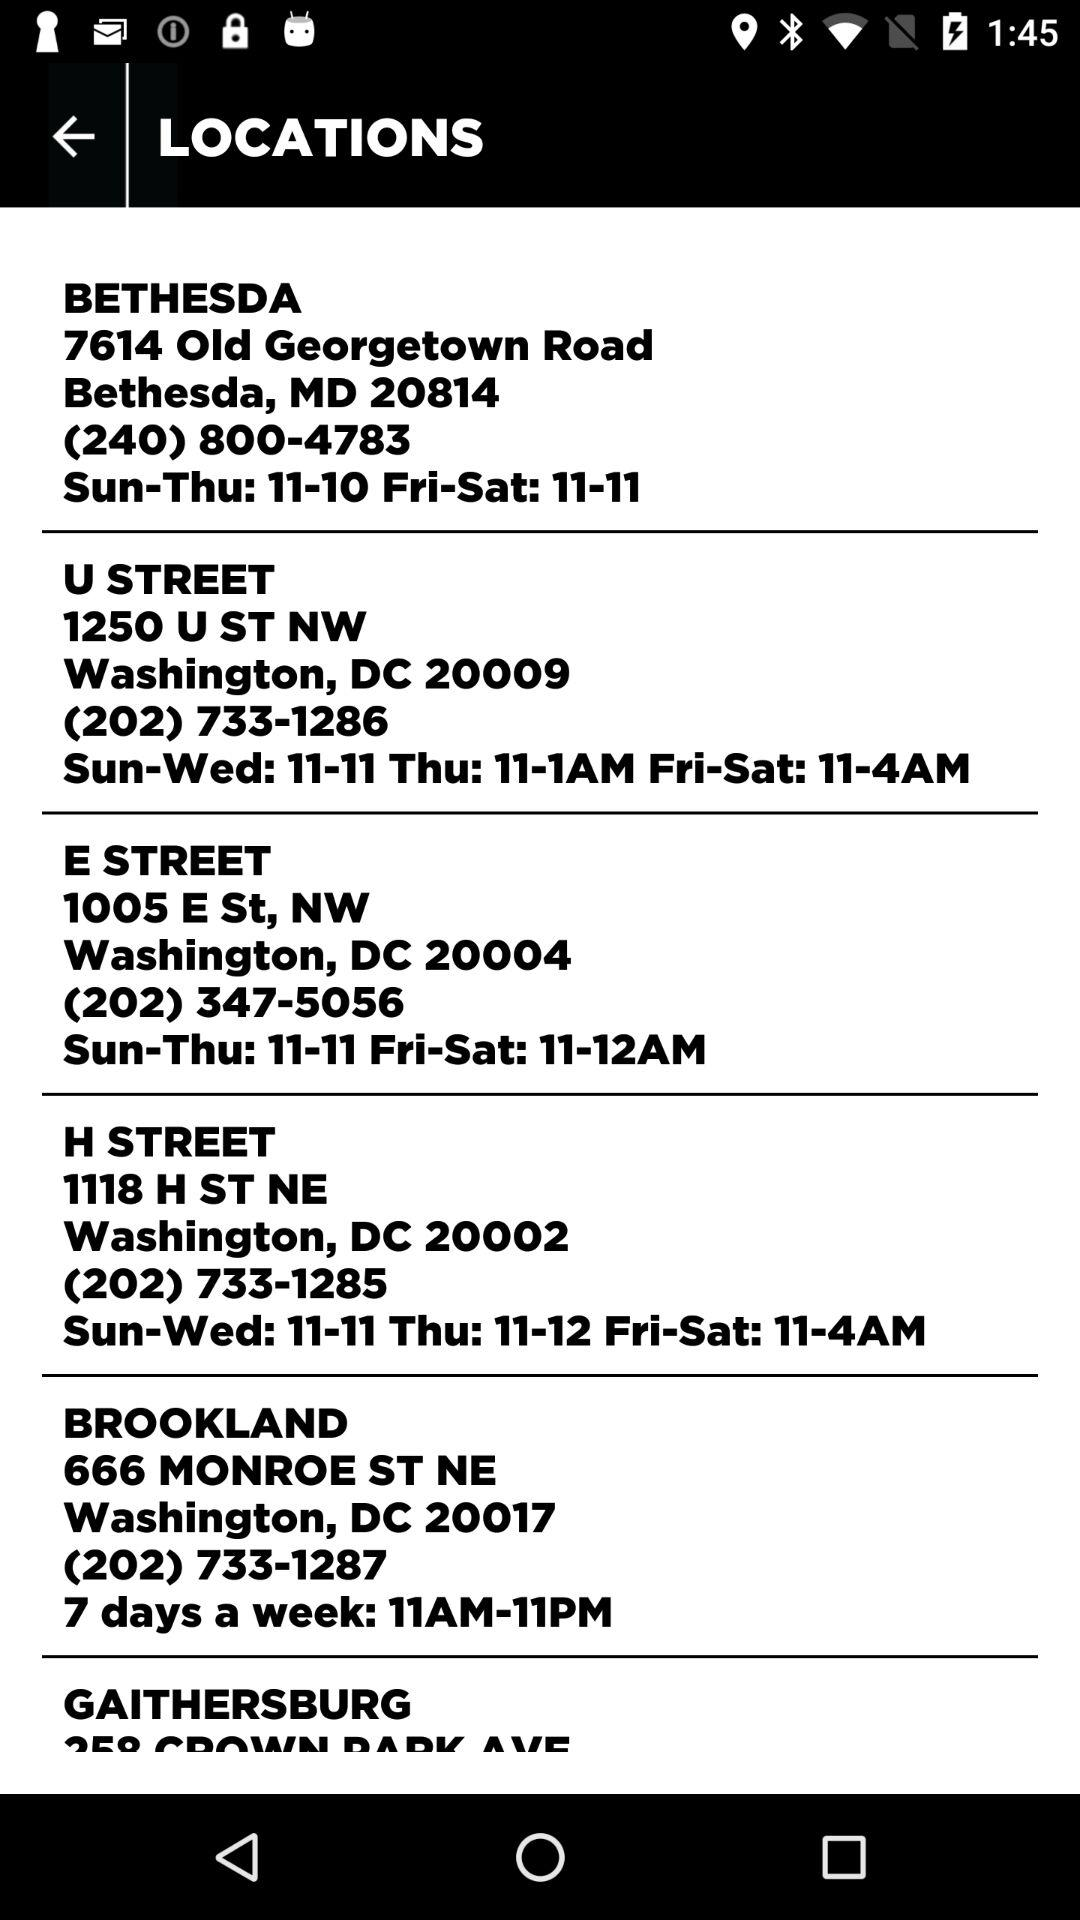What is the postal code for E Street? The postal code for E Street is 20004. 